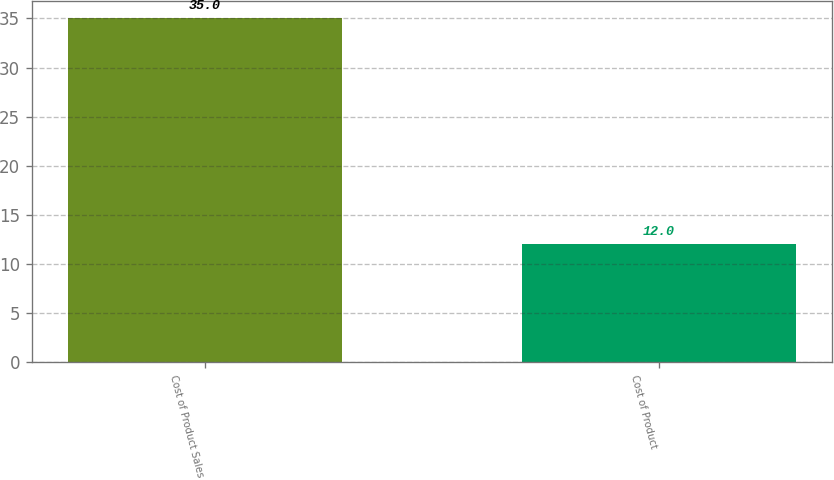Convert chart to OTSL. <chart><loc_0><loc_0><loc_500><loc_500><bar_chart><fcel>Cost of Product Sales<fcel>Cost of Product<nl><fcel>35<fcel>12<nl></chart> 